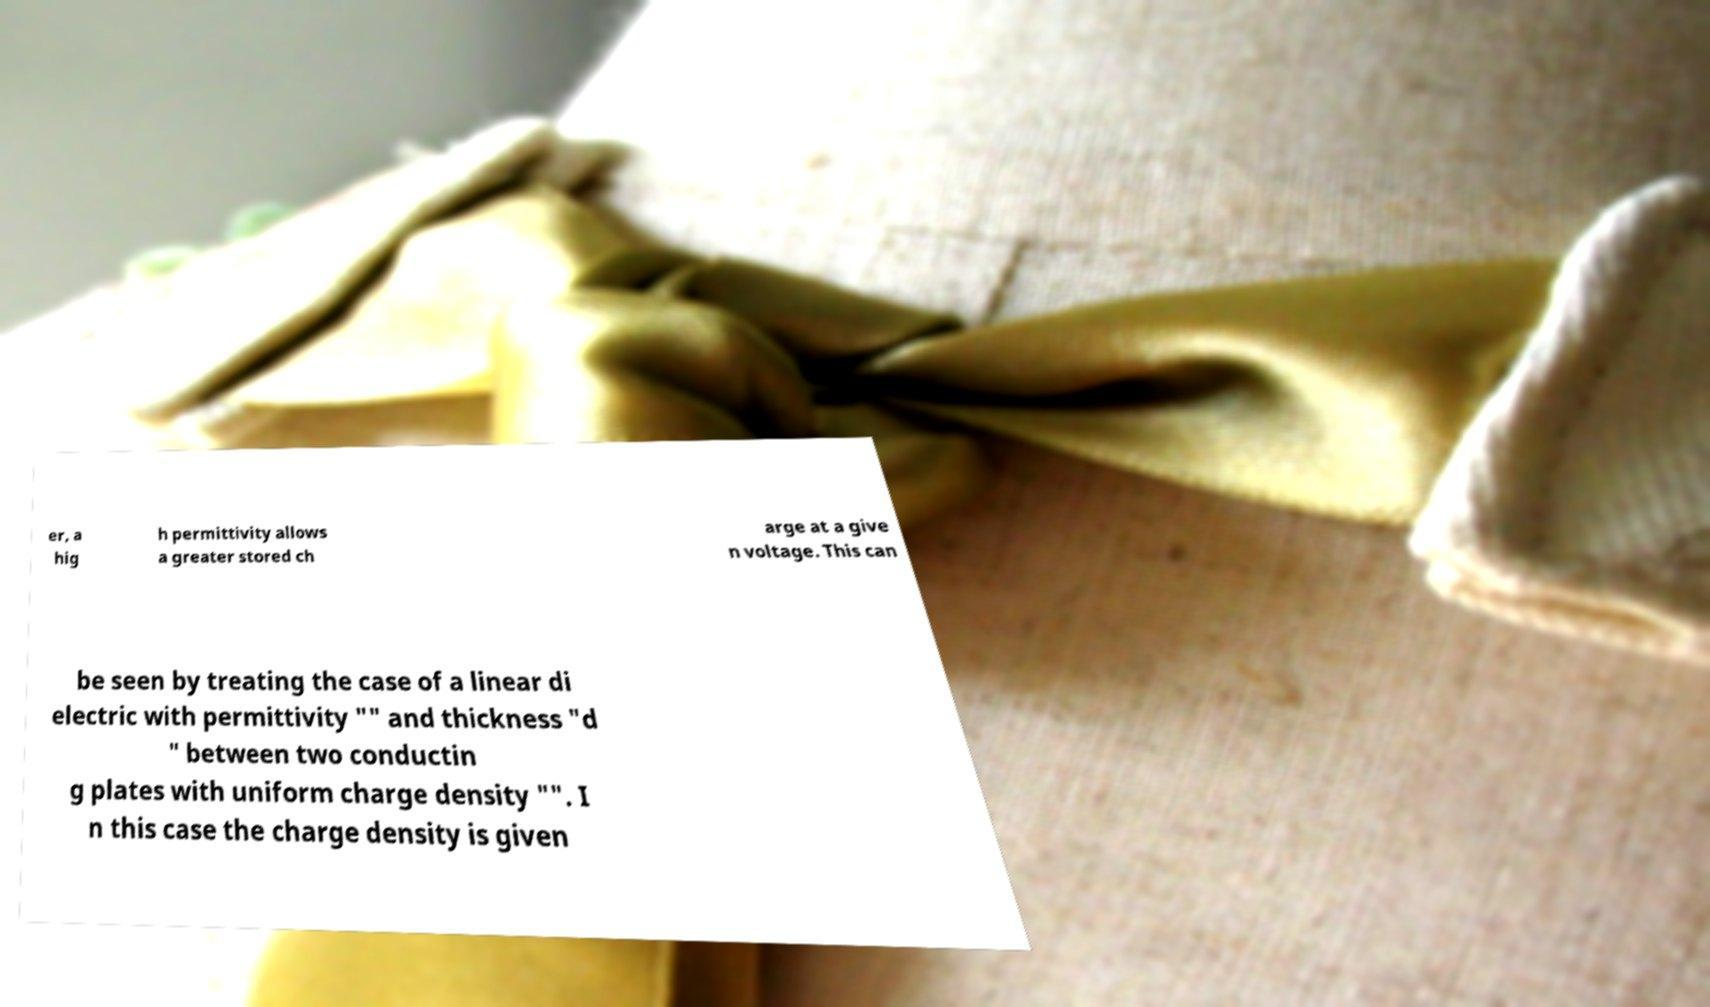Please identify and transcribe the text found in this image. er, a hig h permittivity allows a greater stored ch arge at a give n voltage. This can be seen by treating the case of a linear di electric with permittivity "" and thickness "d " between two conductin g plates with uniform charge density "". I n this case the charge density is given 